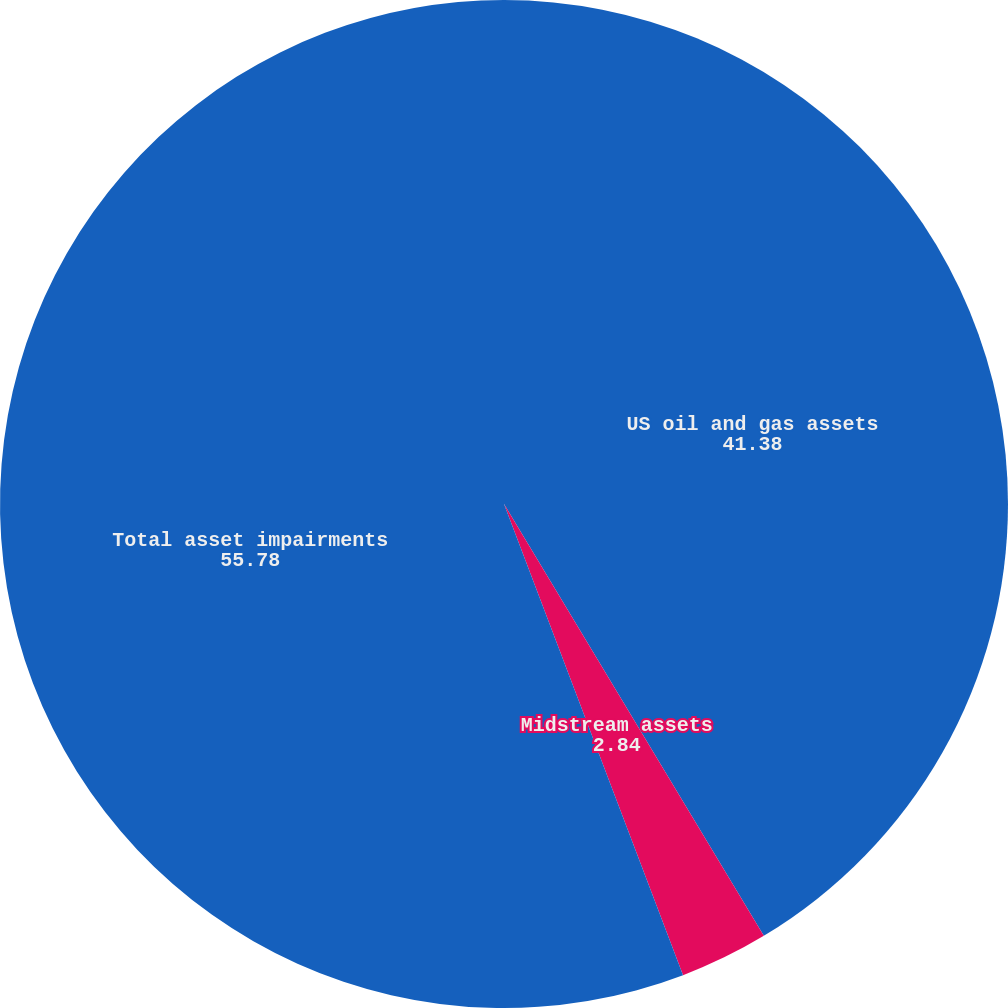Convert chart to OTSL. <chart><loc_0><loc_0><loc_500><loc_500><pie_chart><fcel>US oil and gas assets<fcel>Midstream assets<fcel>Total asset impairments<nl><fcel>41.38%<fcel>2.84%<fcel>55.78%<nl></chart> 